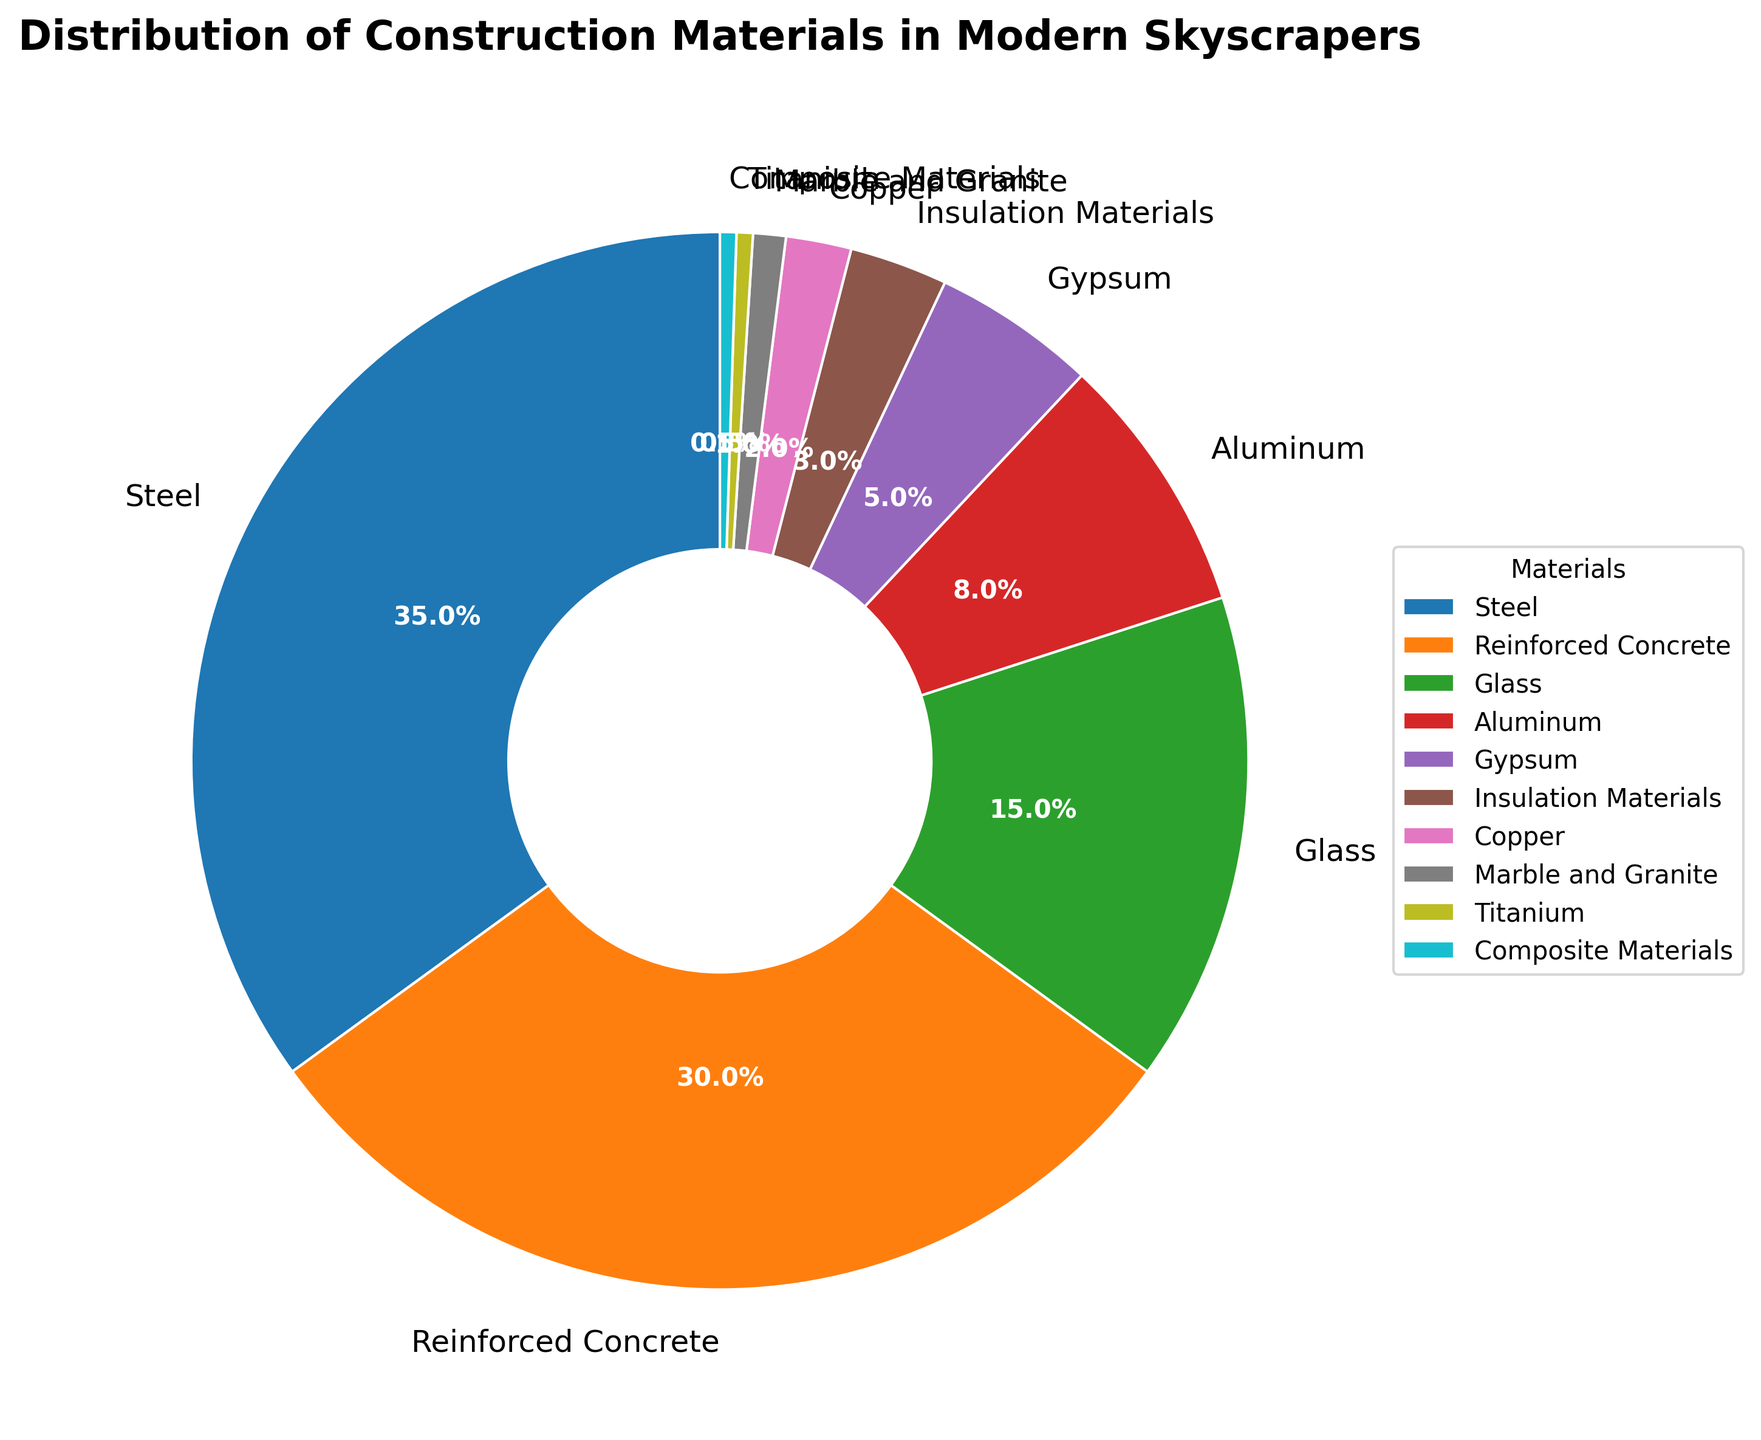What material constitutes the largest percentage in the distribution? To find the material with the largest percentage, refer to the figure and identify the slice of the pie that represents the highest percentage, which is 35%. This slice is labeled "Steel."
Answer: Steel What is the combined percentage of reinforced concrete and glass? Sum the percentages of reinforced concrete (30%) and glass (15%). The total is 30% + 15% = 45%.
Answer: 45% Which material category forms the smallest portion of the pie chart? Identify the smallest slice of the pie by comparing all the percentages. The smallest slice, representing 0.5%, corresponds to both "Titanium" and "Composite Materials."
Answer: Titanium and Composite Materials How much more percentage does steel have compared to aluminum? To determine this, subtract the percentage of aluminum (8%) from the percentage of steel (35%). The difference is 35% - 8% = 27%.
Answer: 27% What are the total percentages of materials that make up less than 5% of the pie chart? Sum the percentages for gypsum (5%), insulation materials (3%), copper (2%), marble and granite (1%), titanium (0.5%), and composite materials (0.5%). The total is 5% + 3% + 2% + 1% + 0.5% + 0.5% = 12%.
Answer: 12% If the industry trend leads to reinforced concrete and glass increasing their proportions by 5%, what will be the new combined percentage for steel, reinforced concrete, and glass? Current percentages are steel (35%), reinforced concrete (30%), and glass (15%). Increasing reinforced concrete and glass by 5% each, the new percentages will be 35% (steel) + 35% (reinforced concrete) + 20% (glass). The combined total will be 35% + 35% + 20% = 90%.
Answer: 90% Which materials have almost the same percentage in the distribution? Compare the percentages visually and identify materials with similar values. "Titanium" and "Composite Materials" both have 0.5%.
Answer: Titanium and Composite Materials Between copper and aluminum, which material has a smaller percentage and by how much? Compare the percentages of copper (2%) and aluminum (8%). Subtract the smaller percentage from the larger one: 8% - 2% = 6%.
Answer: Copper, by 6% What is the percentage that gypsum contributes to the total distribution? Look at the pie chart and identify the percentage associated with gypsum, which is straightforwardly labeled as 5%.
Answer: 5% Excluding steel, what is the percentage contribution of the other materials combined? Subtract the percentage of steel (35%) from the total (100%). The combined percentage of the other materials is 100% - 35% = 65%.
Answer: 65% 